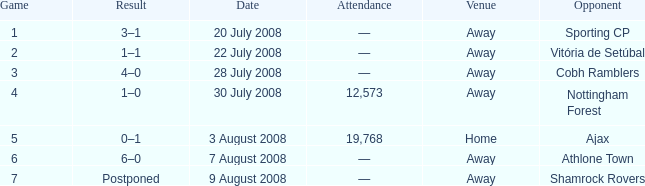What is the result on 20 July 2008? 3–1. 